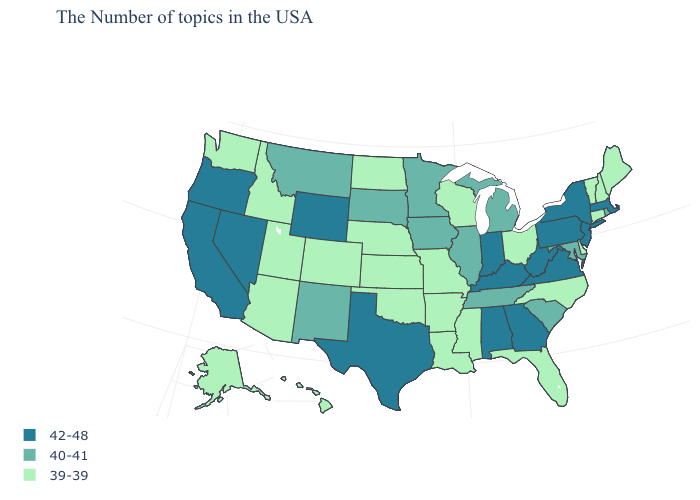Does the map have missing data?
Write a very short answer. No. Among the states that border Utah , does Wyoming have the highest value?
Be succinct. Yes. What is the lowest value in states that border Nevada?
Be succinct. 39-39. Name the states that have a value in the range 39-39?
Write a very short answer. Maine, New Hampshire, Vermont, Connecticut, Delaware, North Carolina, Ohio, Florida, Wisconsin, Mississippi, Louisiana, Missouri, Arkansas, Kansas, Nebraska, Oklahoma, North Dakota, Colorado, Utah, Arizona, Idaho, Washington, Alaska, Hawaii. Which states have the lowest value in the MidWest?
Answer briefly. Ohio, Wisconsin, Missouri, Kansas, Nebraska, North Dakota. Does Vermont have the highest value in the Northeast?
Be succinct. No. Does the first symbol in the legend represent the smallest category?
Write a very short answer. No. Does Wisconsin have the same value as California?
Answer briefly. No. What is the value of Mississippi?
Give a very brief answer. 39-39. Which states have the lowest value in the West?
Give a very brief answer. Colorado, Utah, Arizona, Idaho, Washington, Alaska, Hawaii. Does the first symbol in the legend represent the smallest category?
Write a very short answer. No. What is the value of Pennsylvania?
Give a very brief answer. 42-48. Which states have the lowest value in the South?
Concise answer only. Delaware, North Carolina, Florida, Mississippi, Louisiana, Arkansas, Oklahoma. What is the value of West Virginia?
Short answer required. 42-48. Name the states that have a value in the range 40-41?
Write a very short answer. Rhode Island, Maryland, South Carolina, Michigan, Tennessee, Illinois, Minnesota, Iowa, South Dakota, New Mexico, Montana. 